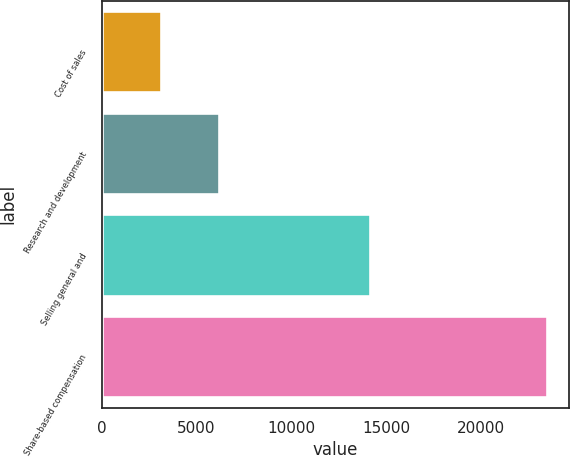<chart> <loc_0><loc_0><loc_500><loc_500><bar_chart><fcel>Cost of sales<fcel>Research and development<fcel>Selling general and<fcel>Share-based compensation<nl><fcel>3129<fcel>6195<fcel>14142<fcel>23466<nl></chart> 